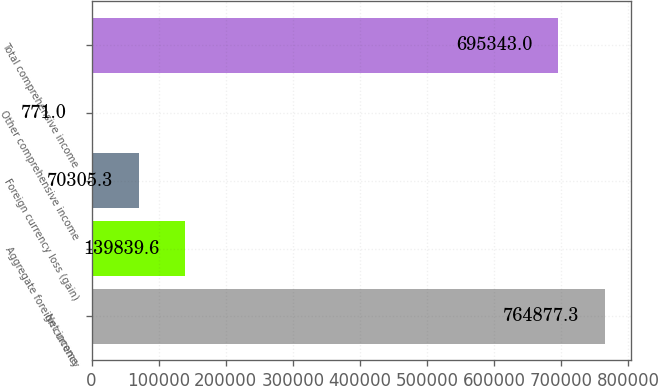<chart> <loc_0><loc_0><loc_500><loc_500><bar_chart><fcel>Net income<fcel>Aggregate foreign currency<fcel>Foreign currency loss (gain)<fcel>Other comprehensive income<fcel>Total comprehensive income<nl><fcel>764877<fcel>139840<fcel>70305.3<fcel>771<fcel>695343<nl></chart> 